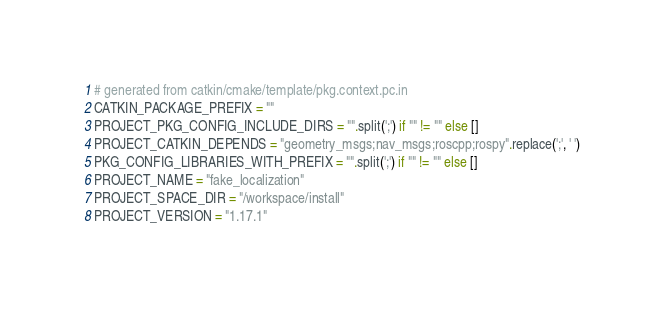Convert code to text. <code><loc_0><loc_0><loc_500><loc_500><_Python_># generated from catkin/cmake/template/pkg.context.pc.in
CATKIN_PACKAGE_PREFIX = ""
PROJECT_PKG_CONFIG_INCLUDE_DIRS = "".split(';') if "" != "" else []
PROJECT_CATKIN_DEPENDS = "geometry_msgs;nav_msgs;roscpp;rospy".replace(';', ' ')
PKG_CONFIG_LIBRARIES_WITH_PREFIX = "".split(';') if "" != "" else []
PROJECT_NAME = "fake_localization"
PROJECT_SPACE_DIR = "/workspace/install"
PROJECT_VERSION = "1.17.1"
</code> 